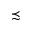Convert formula to latex. <formula><loc_0><loc_0><loc_500><loc_500>\prec s i m</formula> 